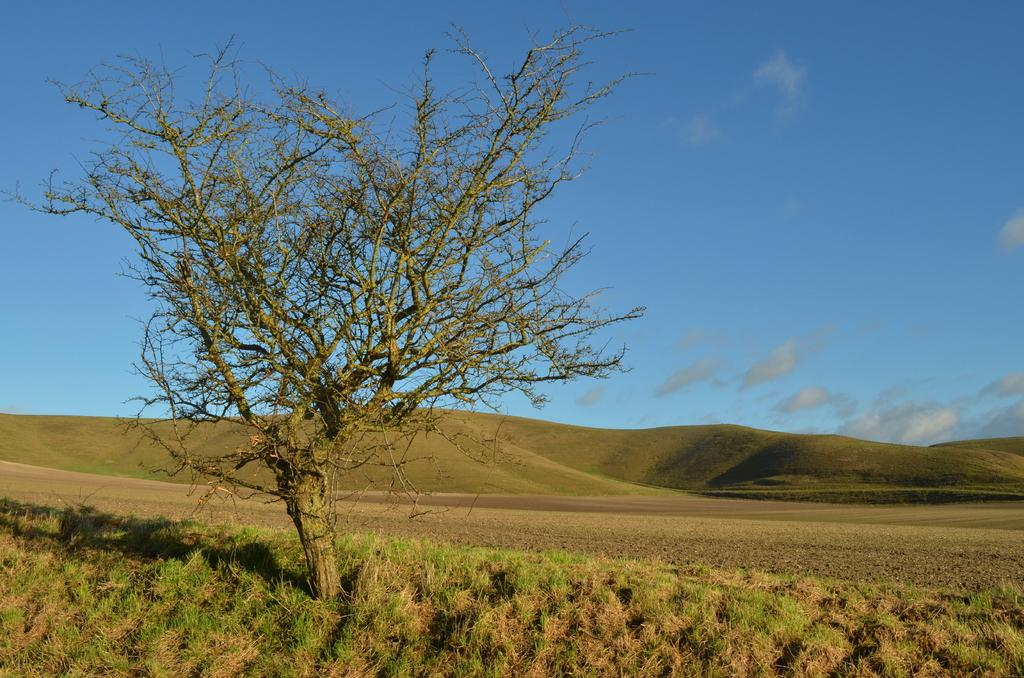What type of vegetation is at the bottom of the image? There is grass at the bottom of the image. What structure can be seen on the left side of the image? There is a tree on the left side of the image. What is visible at the top of the image? The sky is visible at the top of the image. Can you see a receipt for the purchase of a giant's wish in the image? There is no receipt or giant's wish present in the image. What type of giants can be seen in the image? There are no giants present in the image. 